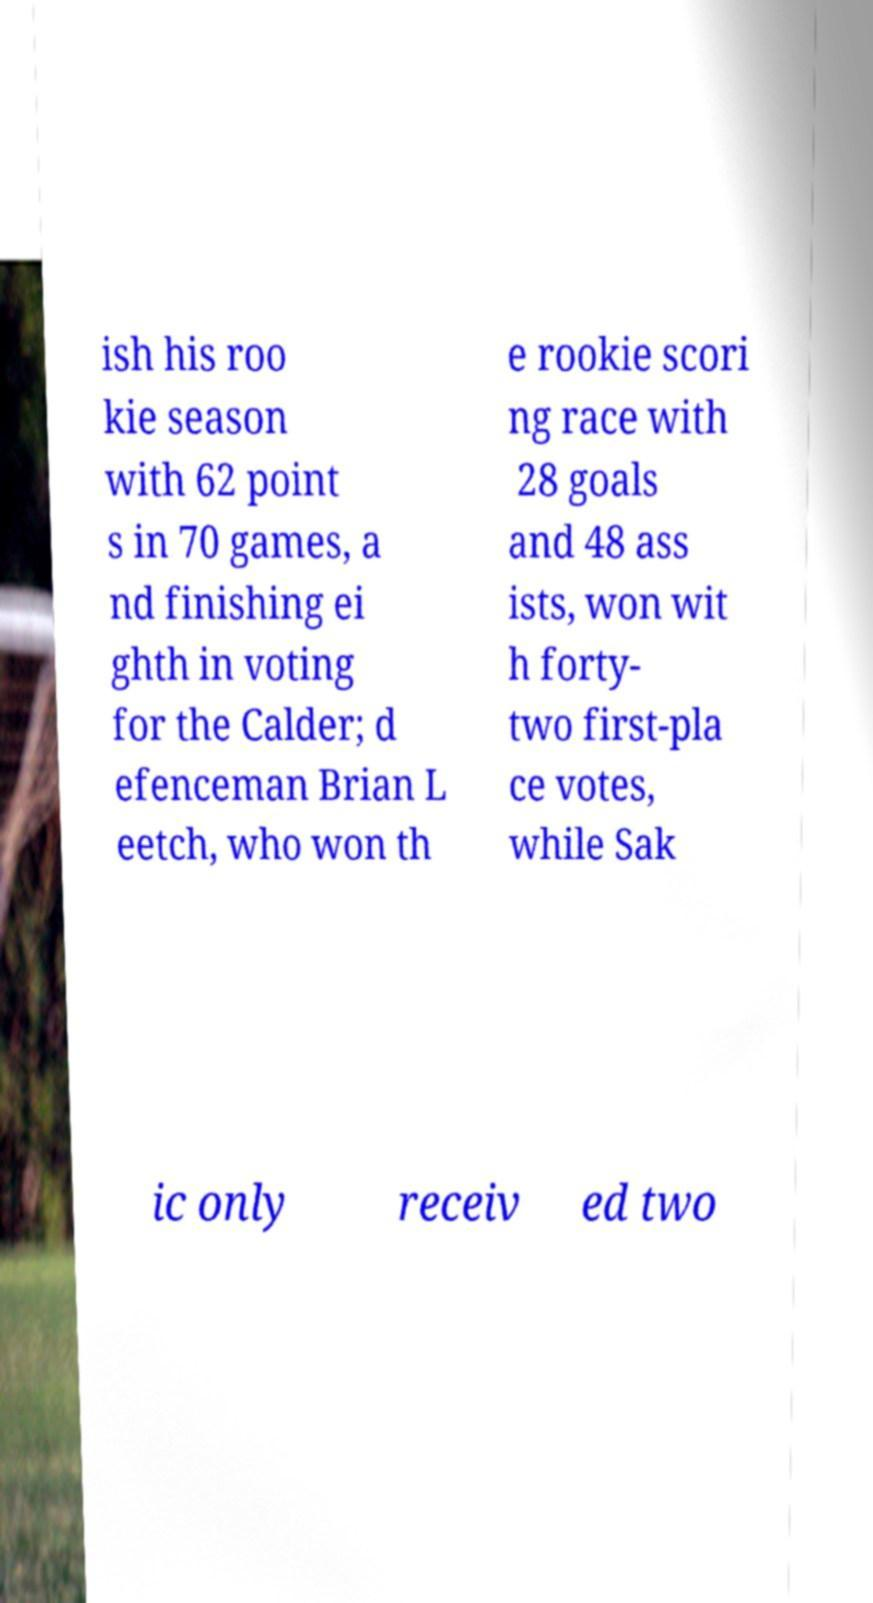Can you accurately transcribe the text from the provided image for me? ish his roo kie season with 62 point s in 70 games, a nd finishing ei ghth in voting for the Calder; d efenceman Brian L eetch, who won th e rookie scori ng race with 28 goals and 48 ass ists, won wit h forty- two first-pla ce votes, while Sak ic only receiv ed two 